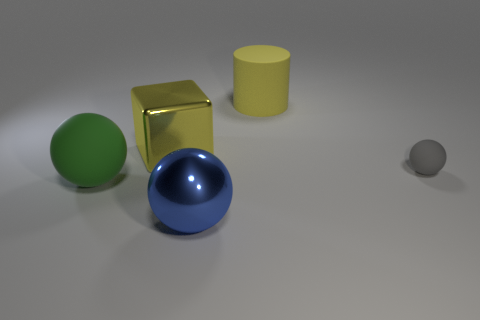Do the small gray sphere and the yellow object that is left of the blue shiny thing have the same material? Based on the image, the small gray sphere appears to have a matte finish, while the yellow object exhibits a more plastic-like sheen, indicating different materials. So no, they do not have the same material. 